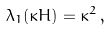Convert formula to latex. <formula><loc_0><loc_0><loc_500><loc_500>\lambda _ { 1 } ( \kappa H ) = \kappa ^ { 2 } \, ,</formula> 